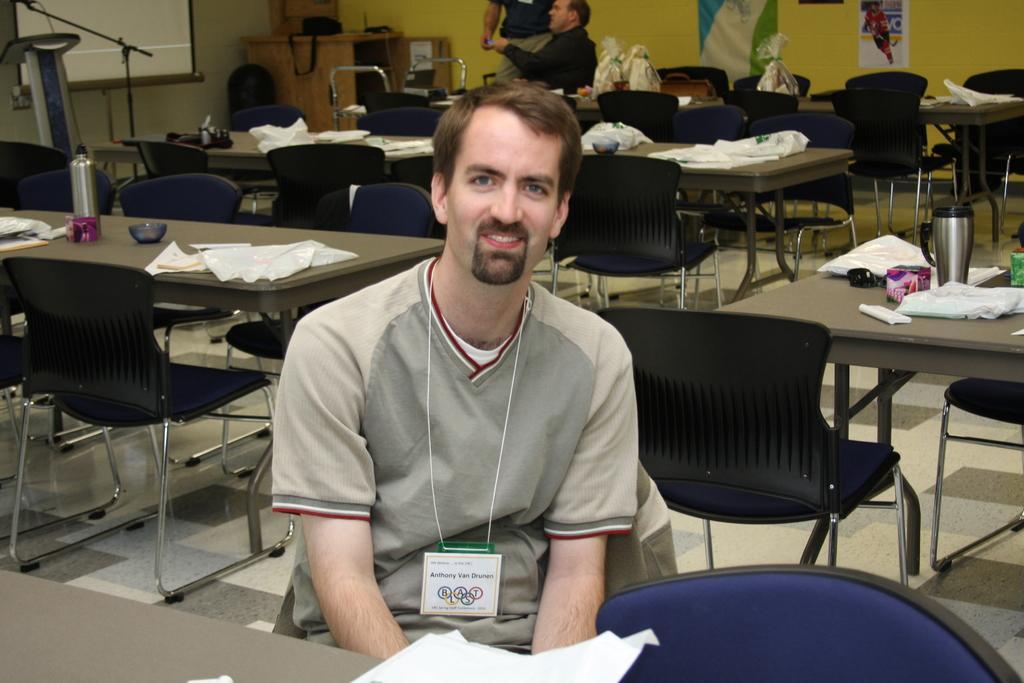In one or two sentences, can you explain what this image depicts? There is a room in which so many tables and chairs are placed in which one man is sitting and other is a projector placed and behind that there are two man one is sitting and other is standing and talking to each other. 